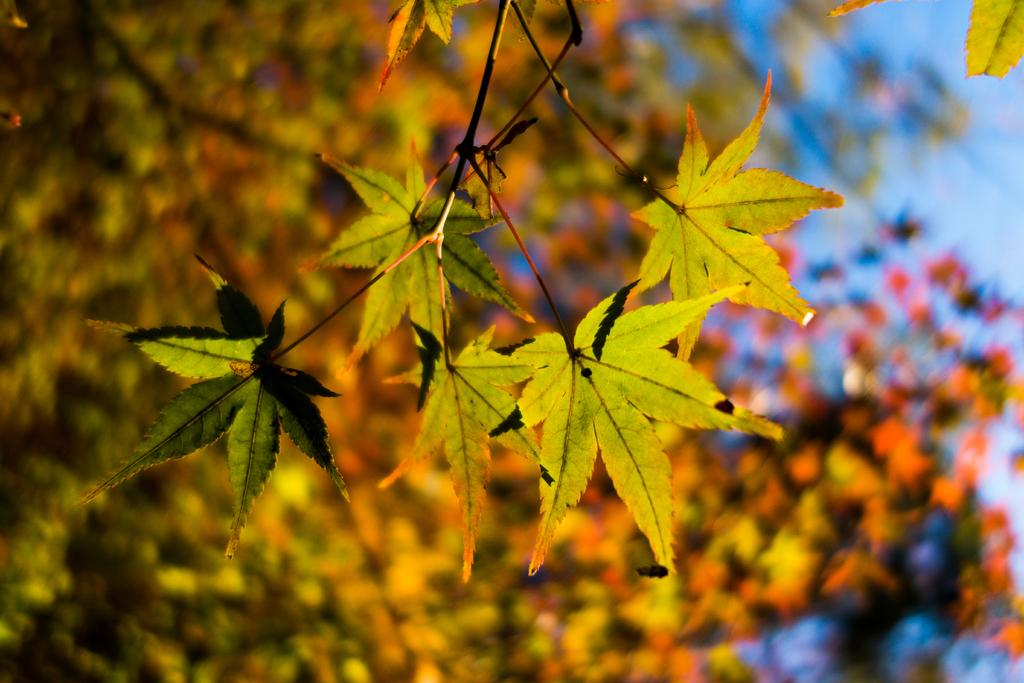What type of vegetation can be seen in the image? There are leaves in the image. What color is the sky in the image? The sky is blue in the image. How would you describe the background of the image? The background of the image is blurred. What type of stick is used to create the silk in the image? There is no stick or silk present in the image. How does the expansion of the leaves affect the image? There is no expansion of the leaves mentioned in the image, and the leaves are not shown to be expanding. 